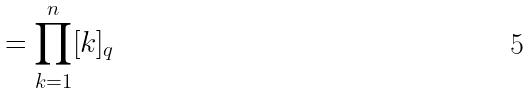Convert formula to latex. <formula><loc_0><loc_0><loc_500><loc_500>= \prod _ { k = 1 } ^ { n } [ k ] _ { q }</formula> 